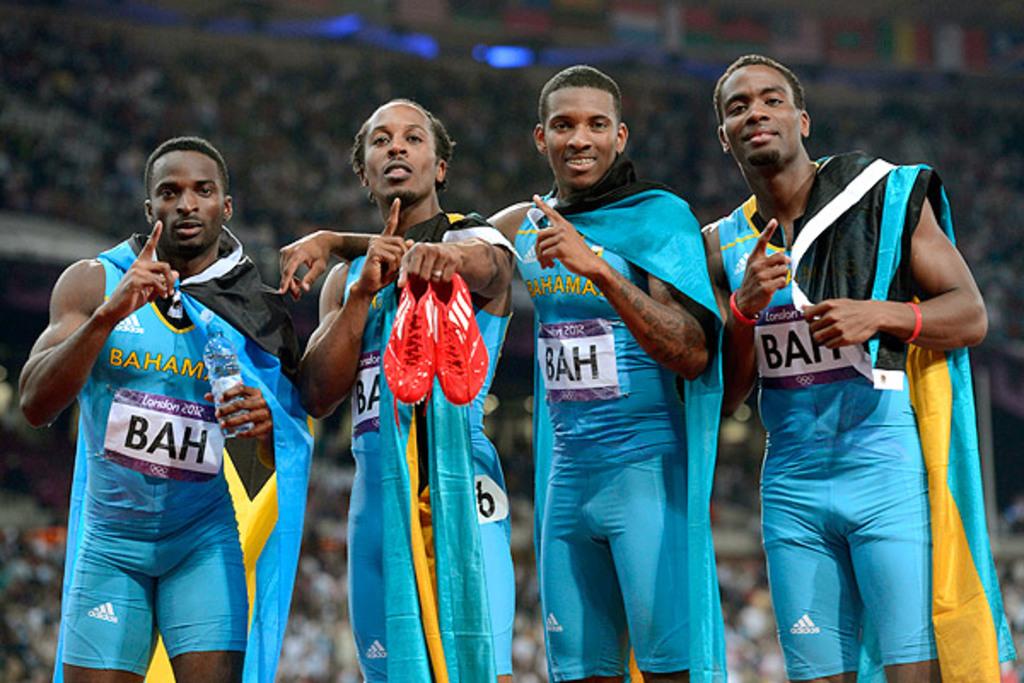What country are these men from?
Your answer should be very brief. Bahamas. What olympic year was this photo taken?
Your answer should be compact. 2012. 